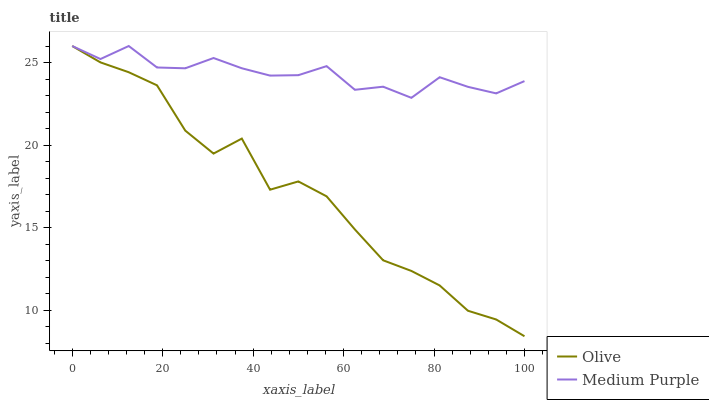Does Medium Purple have the minimum area under the curve?
Answer yes or no. No. Is Medium Purple the roughest?
Answer yes or no. No. Does Medium Purple have the lowest value?
Answer yes or no. No. 